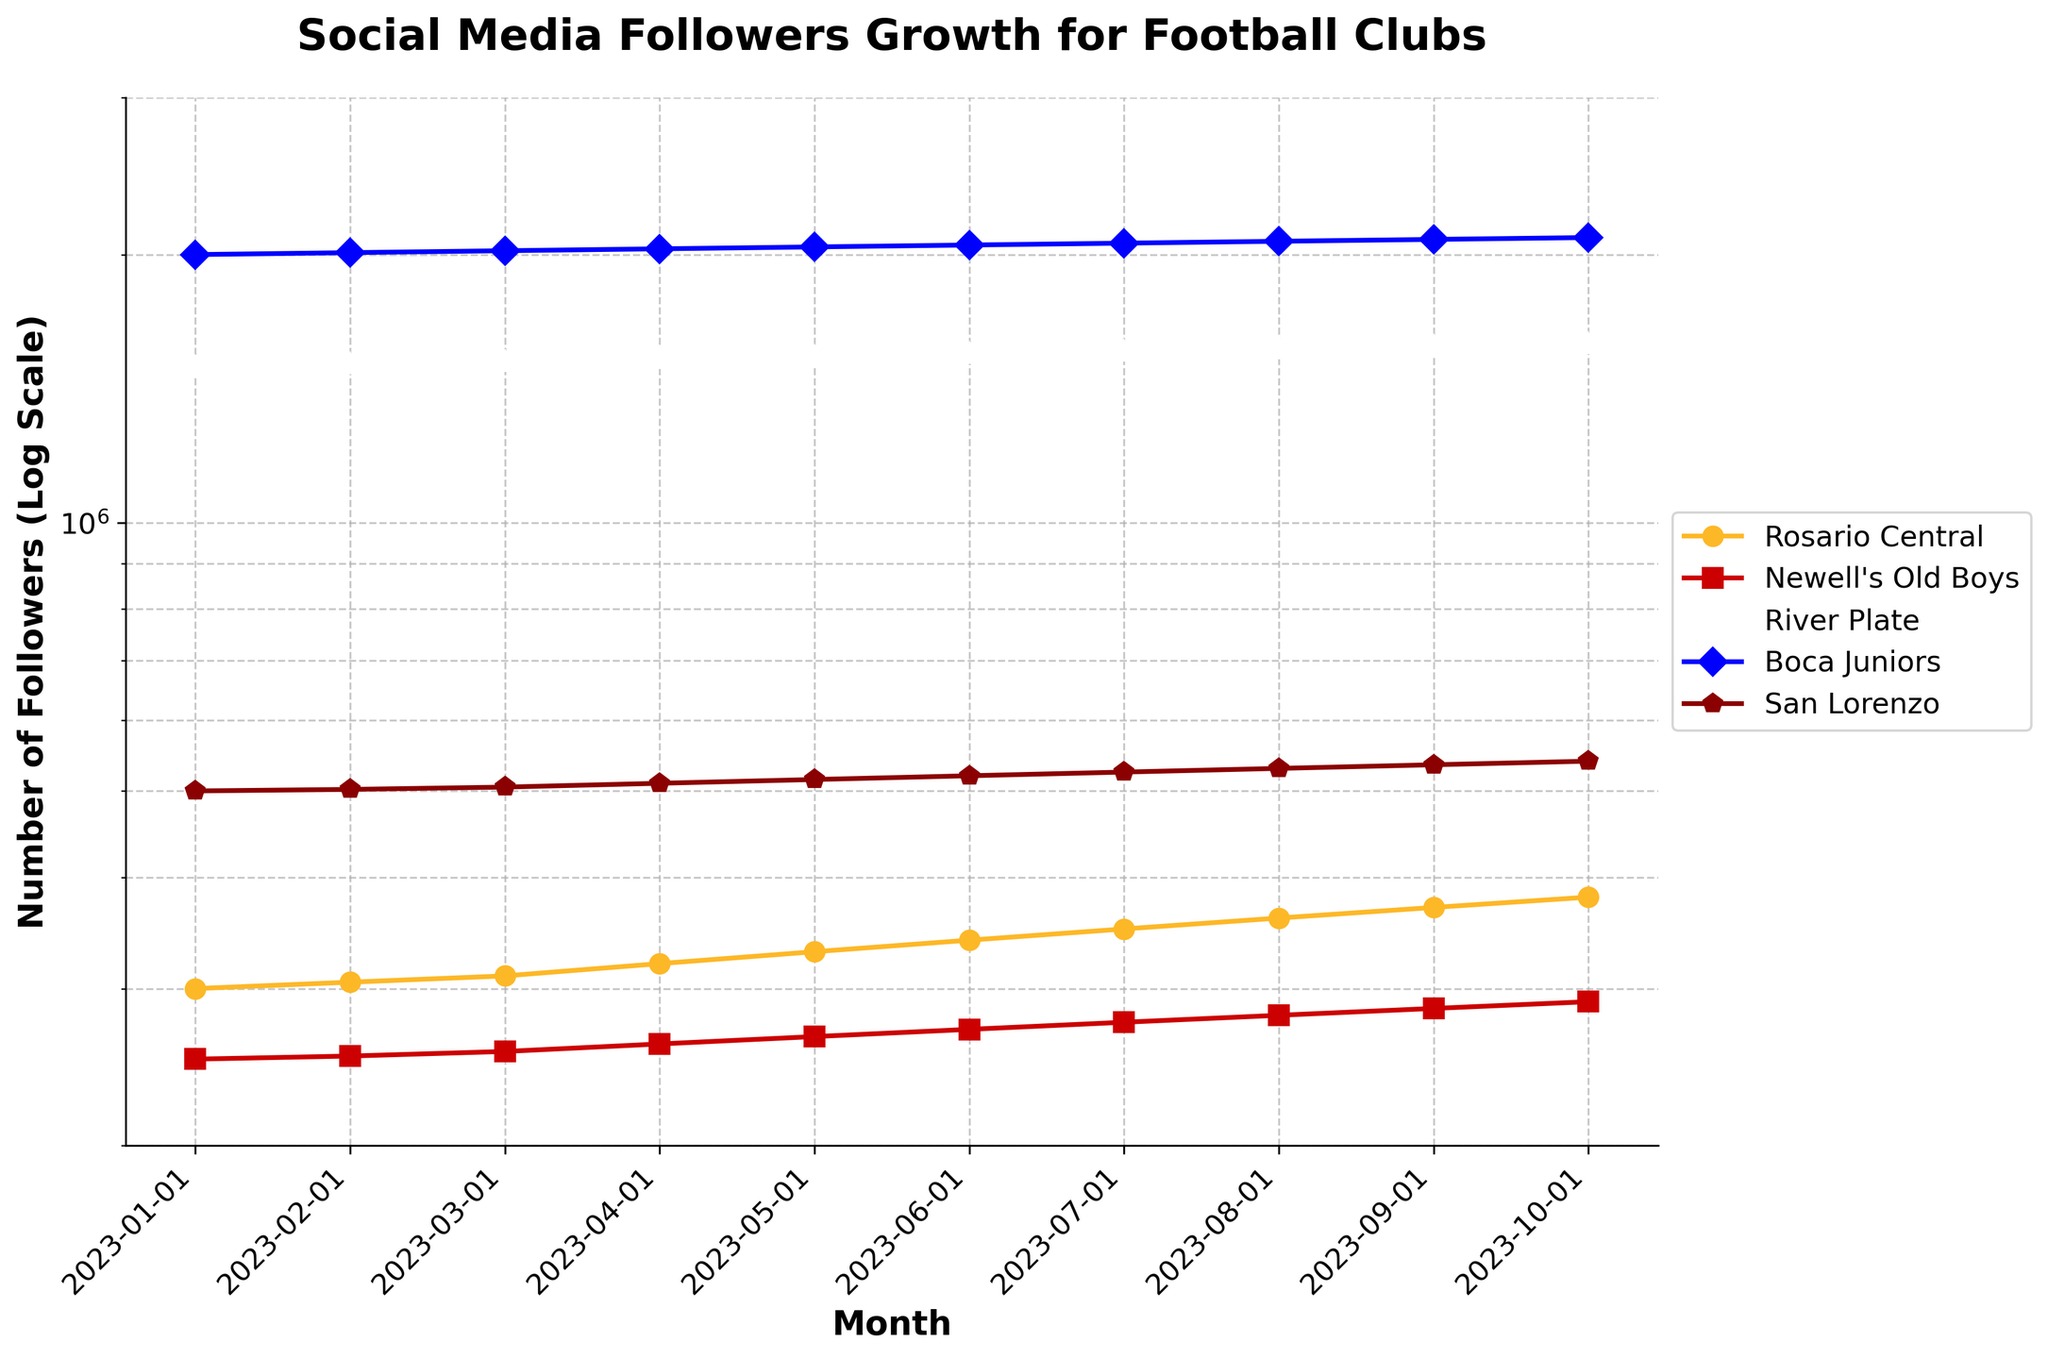what is the title of the plot? The title is usually displayed at the top of the plot in a larger and bold font. For this plot, it reads "Social Media Followers Growth for Football Clubs”.
Answer: Social Media Followers Growth for Football Clubs how many months of data are shown in the plot? The x-axis labels represent months, and there are a total of 10 labels ranging from January 2023 to October 2023. Thus, the plot shows data for 10 months.
Answer: 10 which club has the highest number of followers in October 2023? Look at the plot lines at the rightmost side (October 2023). Boca Juniors' line is the highest, indicating the most followers.
Answer: Boca Juniors in which month did Rosario Central surpass 350,000 followers? Follow the trajectory of Rosario Central's line and identify the point where it first exceeds the 350,000 mark. This occurs in July 2023.
Answer: July 2023 how does the number of followers for Newell's Old Boys in april 2023 compare to that of San Lorenzo in the same month? Locate the April 2023 data points for both Newell's Old Boys and San Lorenzo. Newell's Old Boys had 260,000 followers while San Lorenzo had 510,000 followers. Since 510,000 > 260,000, San Lorenzo had more followers.
Answer: San Lorenzo has more followers what is the overall trend in the number of followers for Rosario Central from january 2023 to october 2023? Examine the progression of Rosario Central's line throughout the plot. It's consistently increasing month by month. Therefore, the overall trend is upward.
Answer: Upward trend which club shows the fastest growth rate in this period? Compare the slopes of the lines for each club. The steepest slope indicates the fastest growth rate. Boca Juniors' line appears steepest, indicating the fastest growth.
Answer: Boca Juniors what is the difference in the number of followers between Rosario Central and River Plate in october 2023? Look at the data points for Rosario Central and River Plate in October 2023. Rosario Central has 380,000 followers, and River Plate has 1,590,000 followers. The difference is 1,590,000 - 380,000 = 1,210,000 followers.
Answer: 1,210,000 followers by what percentage did Rosario Central's followers increase from january 2023 to october 2023? Calculate the increase in followers: 380,000 (October) - 300,000 (January) = 80,000. Then divide this by the original amount: 80,000 / 300,000 = 0.2667. Multiply by 100 to get the percentage: 0.2667 * 100 ≈ 26.67%.
Answer: 26.67% how does the number of followers for Boca Juniors in February 2023 compare to that of April 2023? Identify the data points for Boca Juniors in February 2023 (2,010,000) and April 2023 (2,030,000). The increase is 2,030,000 - 2,010,000 = 20,000 followers.
Answer: 20,000 more followers in April 2023 